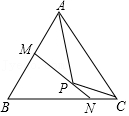Summarize the features presented in the diagram. The diagram shows a triangle with three vertices labeled A, B, and C. Inside the triangle, there is a point labeled P. A line labeled MN passes through point P, intersecting sides AB and BC at points M and N respectively. Point M lies on the perpendicular bisector of segment PA, while point N lies on the perpendicular bisector of segment PC. 